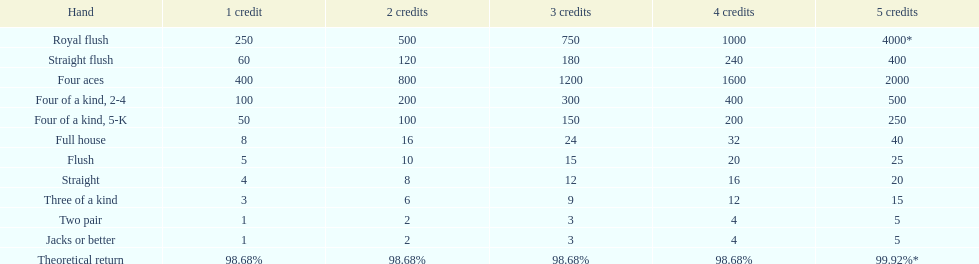Could you help me parse every detail presented in this table? {'header': ['Hand', '1 credit', '2 credits', '3 credits', '4 credits', '5 credits'], 'rows': [['Royal flush', '250', '500', '750', '1000', '4000*'], ['Straight flush', '60', '120', '180', '240', '400'], ['Four aces', '400', '800', '1200', '1600', '2000'], ['Four of a kind, 2-4', '100', '200', '300', '400', '500'], ['Four of a kind, 5-K', '50', '100', '150', '200', '250'], ['Full house', '8', '16', '24', '32', '40'], ['Flush', '5', '10', '15', '20', '25'], ['Straight', '4', '8', '12', '16', '20'], ['Three of a kind', '3', '6', '9', '12', '15'], ['Two pair', '1', '2', '3', '4', '5'], ['Jacks or better', '1', '2', '3', '4', '5'], ['Theoretical return', '98.68%', '98.68%', '98.68%', '98.68%', '99.92%*']]} What is meant by the hands? Royal flush, Straight flush, Four aces, Four of a kind, 2-4, Four of a kind, 5-K, Full house, Flush, Straight, Three of a kind, Two pair, Jacks or better. Which one is located in the upper position? Royal flush. 